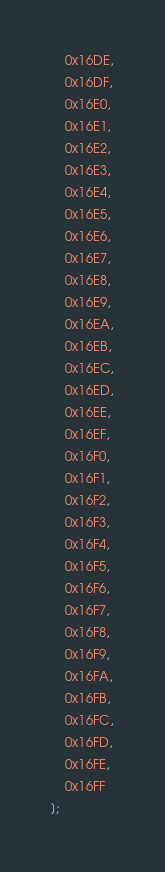Convert code to text. <code><loc_0><loc_0><loc_500><loc_500><_JavaScript_>	0x16DE,
	0x16DF,
	0x16E0,
	0x16E1,
	0x16E2,
	0x16E3,
	0x16E4,
	0x16E5,
	0x16E6,
	0x16E7,
	0x16E8,
	0x16E9,
	0x16EA,
	0x16EB,
	0x16EC,
	0x16ED,
	0x16EE,
	0x16EF,
	0x16F0,
	0x16F1,
	0x16F2,
	0x16F3,
	0x16F4,
	0x16F5,
	0x16F6,
	0x16F7,
	0x16F8,
	0x16F9,
	0x16FA,
	0x16FB,
	0x16FC,
	0x16FD,
	0x16FE,
	0x16FF
];</code> 